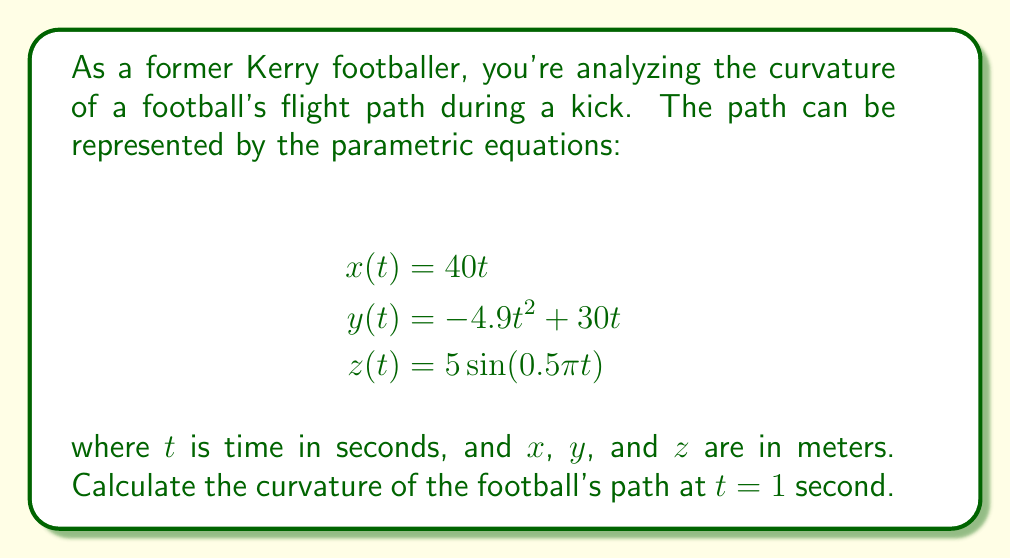Teach me how to tackle this problem. To find the curvature of a parametric curve at a given point, we can use the formula:

$$\kappa = \frac{\sqrt{|\mathbf{r}'(t) \times \mathbf{r}''(t)|^2}}{|\mathbf{r}'(t)|^3}$$

Where $\mathbf{r}(t) = \langle x(t), y(t), z(t) \rangle$ is the position vector.

Step 1: Calculate $\mathbf{r}'(t)$ and $\mathbf{r}''(t)$
$\mathbf{r}'(t) = \langle 40, -9.8t + 30, 2.5\pi\cos(0.5\pi t) \rangle$
$\mathbf{r}''(t) = \langle 0, -9.8, -1.25\pi^2\sin(0.5\pi t) \rangle$

Step 2: Evaluate $\mathbf{r}'(1)$ and $\mathbf{r}''(1)$
$\mathbf{r}'(1) = \langle 40, 20.2, 2.5\pi\cos(0.5\pi) \rangle \approx \langle 40, 20.2, 0 \rangle$
$\mathbf{r}''(1) = \langle 0, -9.8, -1.25\pi^2\sin(0.5\pi) \rangle \approx \langle 0, -9.8, -3.90 \rangle$

Step 3: Calculate the cross product $\mathbf{r}'(1) \times \mathbf{r}''(1)$
$\mathbf{r}'(1) \times \mathbf{r}''(1) = \langle -78.68, -156, 392 \rangle$

Step 4: Calculate $|\mathbf{r}'(1) \times \mathbf{r}''(1)|^2$
$|\mathbf{r}'(1) \times \mathbf{r}''(1)|^2 = (-78.68)^2 + (-156)^2 + 392^2 \approx 183,184.5$

Step 5: Calculate $|\mathbf{r}'(1)|^3$
$|\mathbf{r}'(1)|^3 = (40^2 + 20.2^2 + 0^2)^{3/2} \approx 252,317.6$

Step 6: Apply the curvature formula
$$\kappa = \frac{\sqrt{183,184.5}}{252,317.6} \approx 0.0170$$
Answer: The curvature of the football's flight path at $t = 1$ second is approximately 0.0170 m^(-1). 